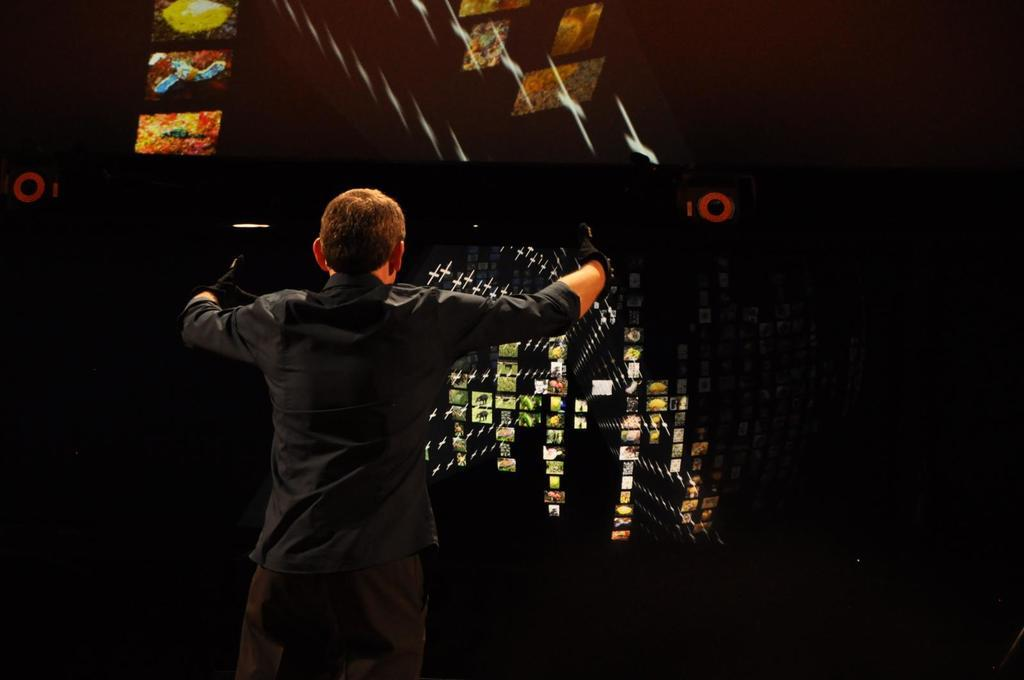What is the main subject of the image? There is a person standing in the image. What is the person doing in the image? The person is looking at a cluster of images. What type of neck is visible in the image? There is no neck visible in the image; the focus is on the person standing and looking at a cluster of images. 